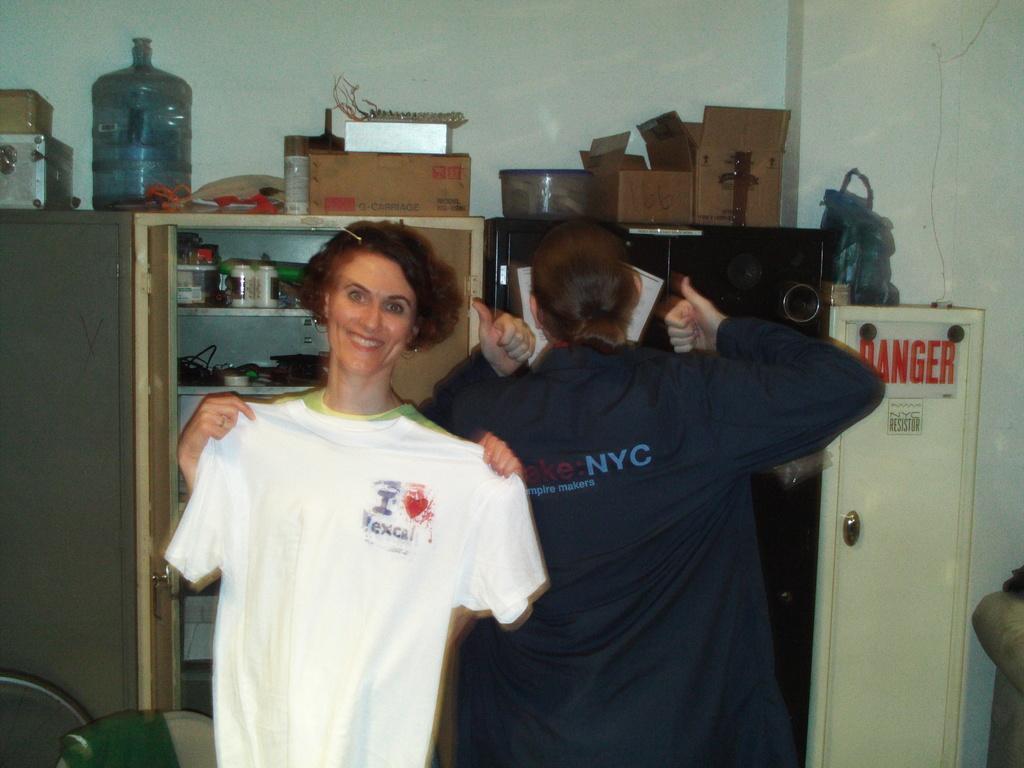Describe this image in one or two sentences. In the picture we can find a man and two women standing, one woman is facing front and one woman is facing background. In the background we can find some racks and cupboard and some things on it. 